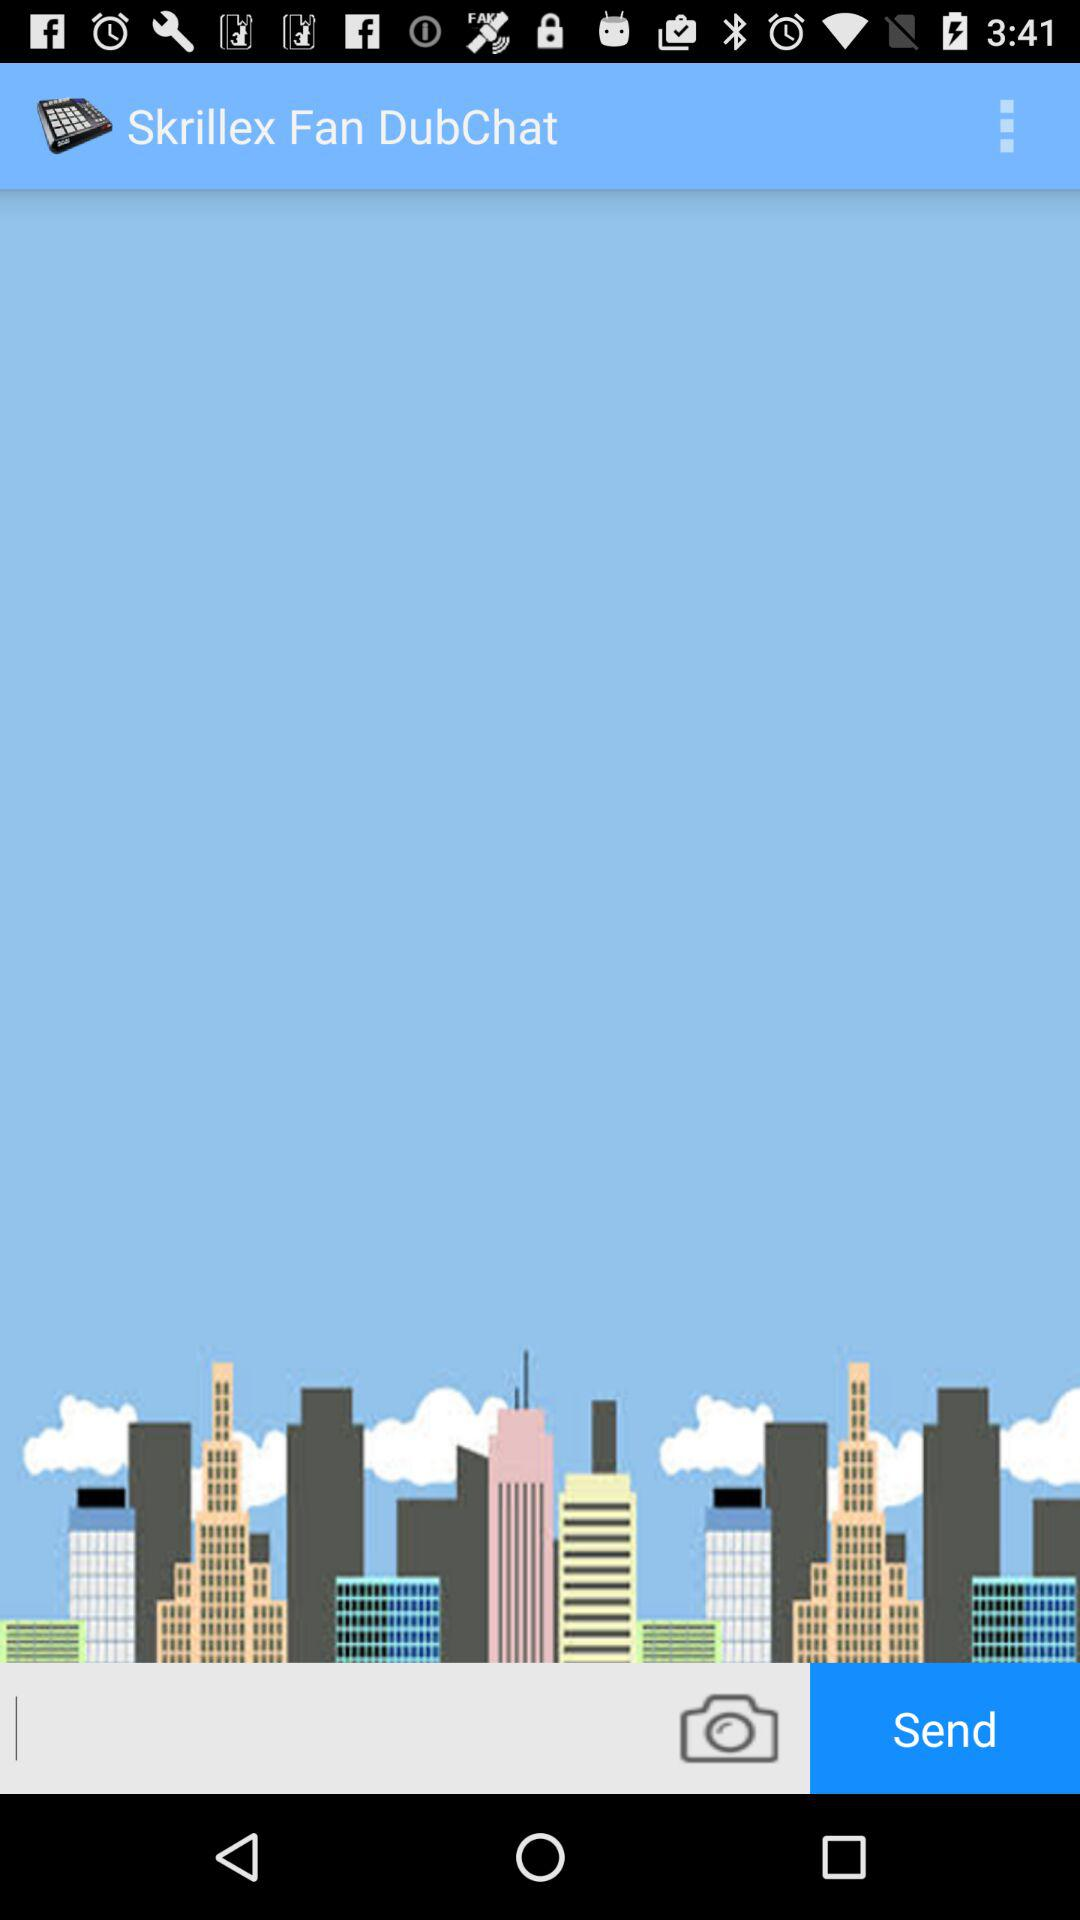What is the application name? The application name is "Skrillex Fan DubChat". 